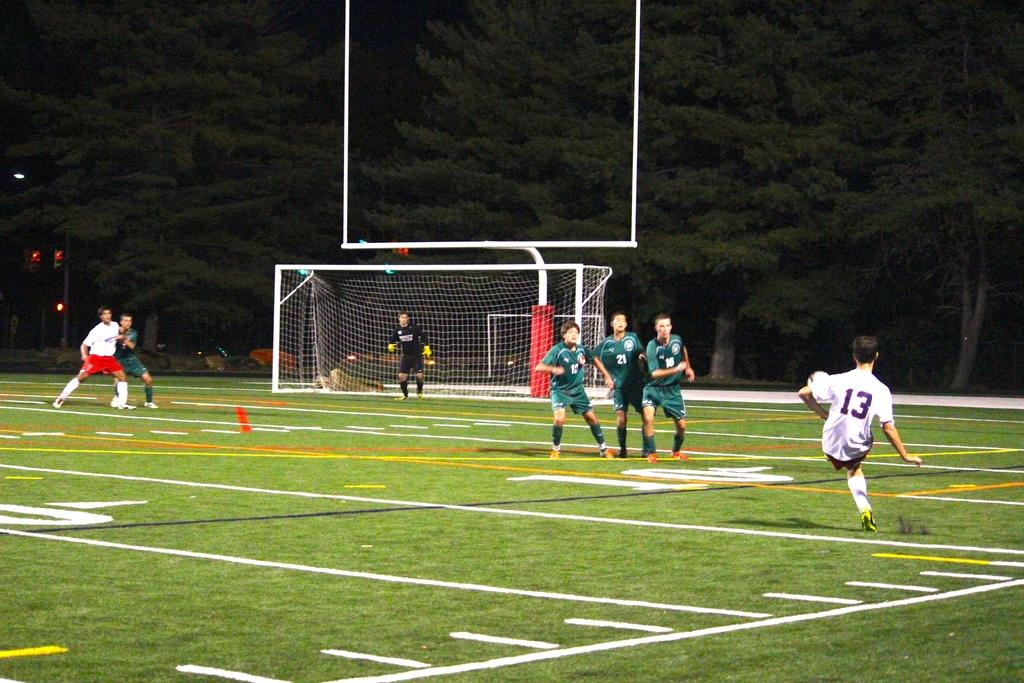<image>
Provide a brief description of the given image. A soccer player with the number 13 on his jersey kicks a soccer ball. 